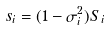<formula> <loc_0><loc_0><loc_500><loc_500>s _ { i } = ( 1 - \sigma ^ { 2 } _ { i } ) S _ { i }</formula> 